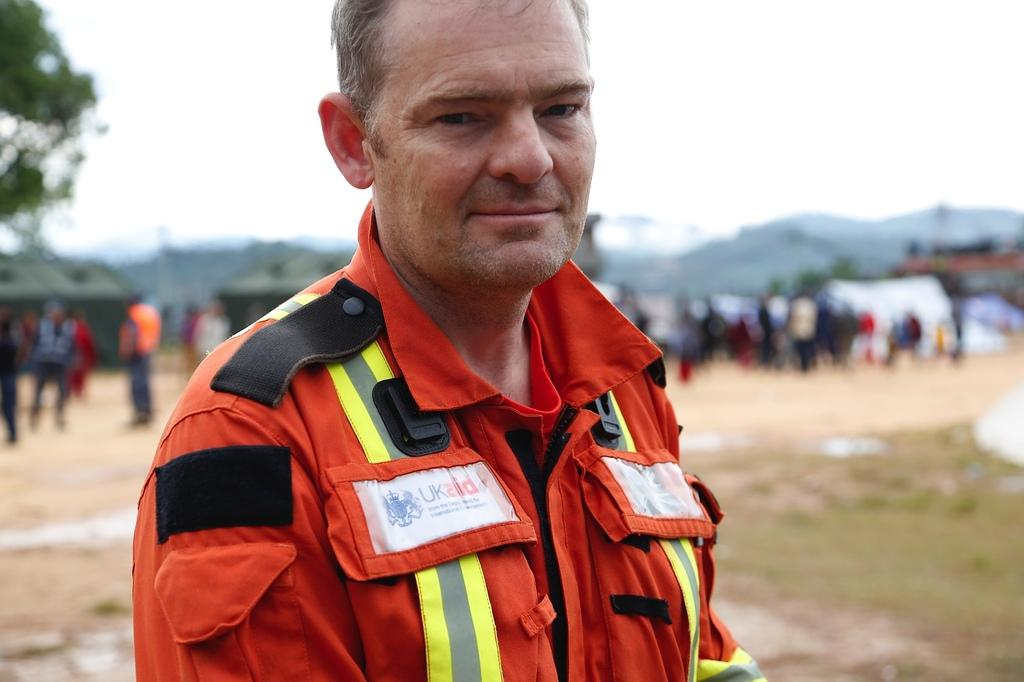What is the main subject of the image? There is a man standing in the image. Can you describe the people behind the man? The people behind the man are blurred. What can be seen in the background of the image? There is a tree, hills, and the sky visible in the background. What type of worm can be seen crawling on the man's shoulder in the image? There is no worm present on the man's shoulder in the image. Is there a donkey visible in the background of the image? No, there is no donkey visible in the image; only a tree, hills, and the sky are present in the background. 